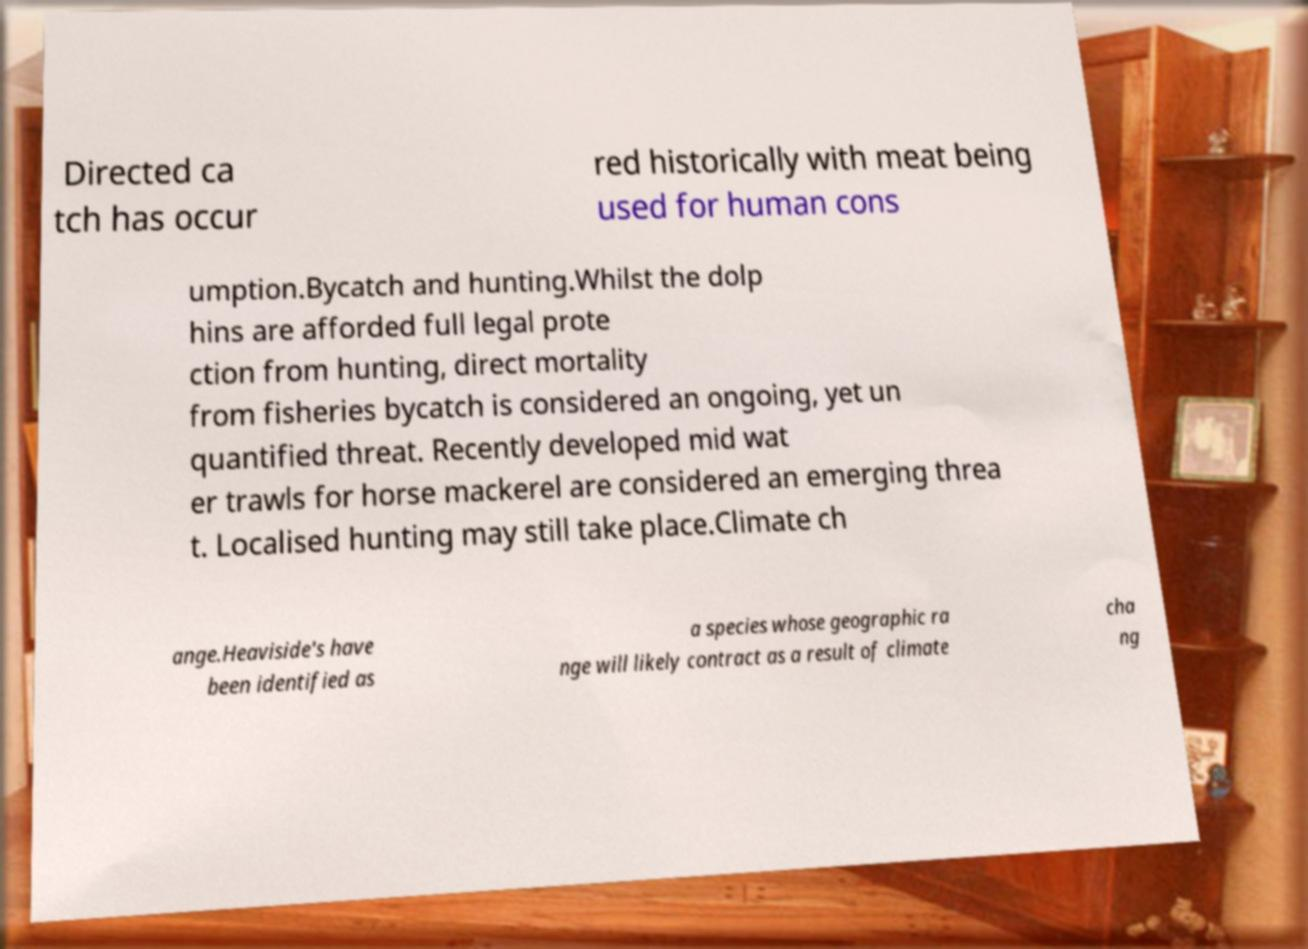What messages or text are displayed in this image? I need them in a readable, typed format. Directed ca tch has occur red historically with meat being used for human cons umption.Bycatch and hunting.Whilst the dolp hins are afforded full legal prote ction from hunting, direct mortality from fisheries bycatch is considered an ongoing, yet un quantified threat. Recently developed mid wat er trawls for horse mackerel are considered an emerging threa t. Localised hunting may still take place.Climate ch ange.Heaviside's have been identified as a species whose geographic ra nge will likely contract as a result of climate cha ng 